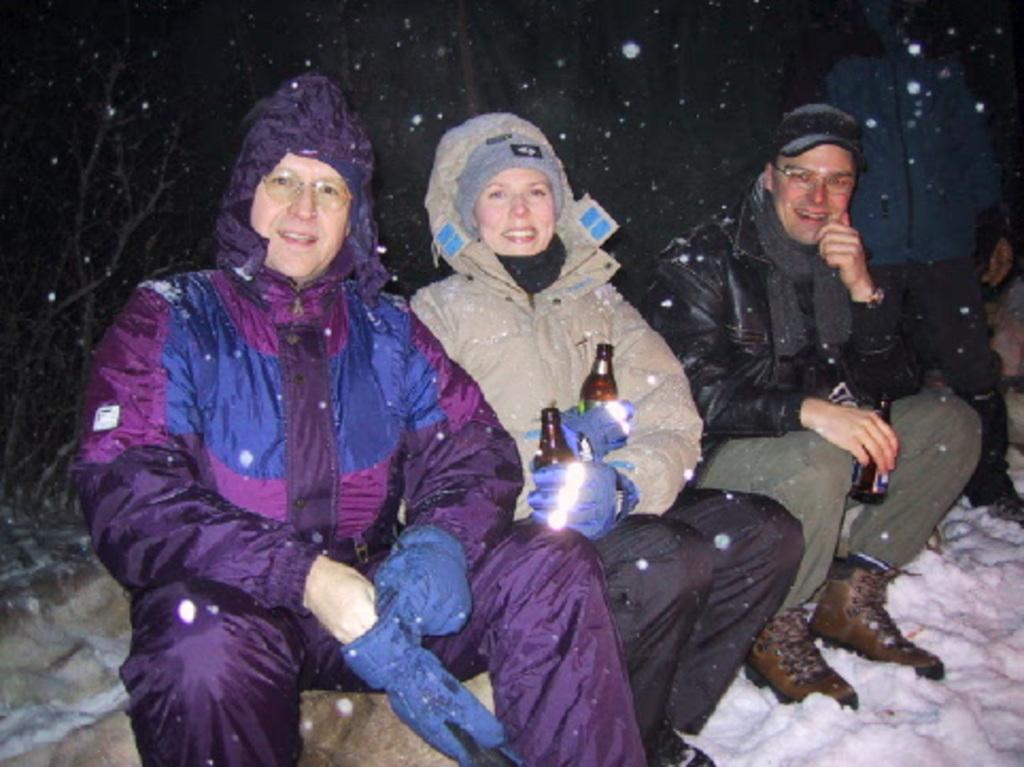What are the people in the image wearing? The people in the image are wearing jackets. What are the people holding in their hands? Two people are holding bottles. What is the condition of the land in the image? The land is covered with snow. What type of flesh can be seen in the image? There is no flesh visible in the image; the people are wearing jackets and holding bottles. Can you tell me how many lockets are present in the image? There are no lockets present in the image. 